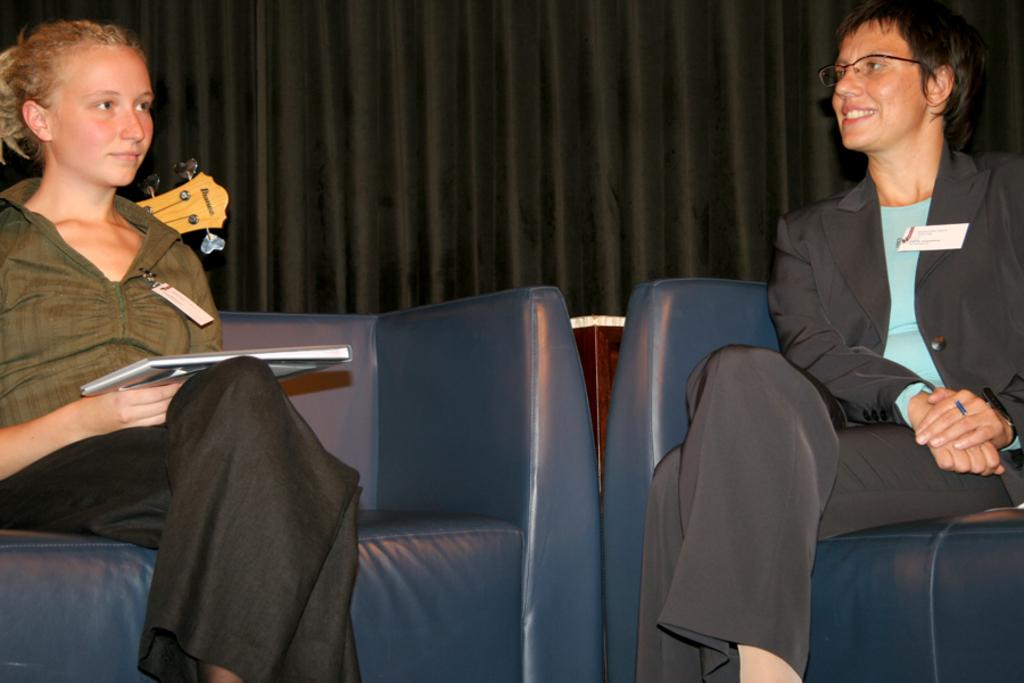Who or what can be seen in the image? There are people in the image. What are the people doing in the image? The people are sitting on a sofa. What type of tank can be seen in the image? There is no tank present in the image; it features people sitting on a sofa. How many robins are visible on the side of the sofa in the image? There are no robins present in the image. 